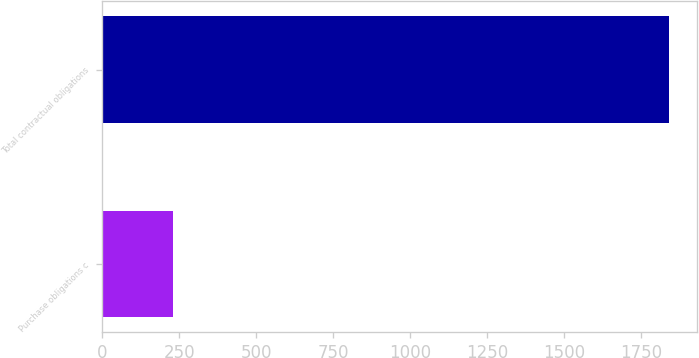<chart> <loc_0><loc_0><loc_500><loc_500><bar_chart><fcel>Purchase obligations c<fcel>Total contractual obligations<nl><fcel>228<fcel>1842<nl></chart> 